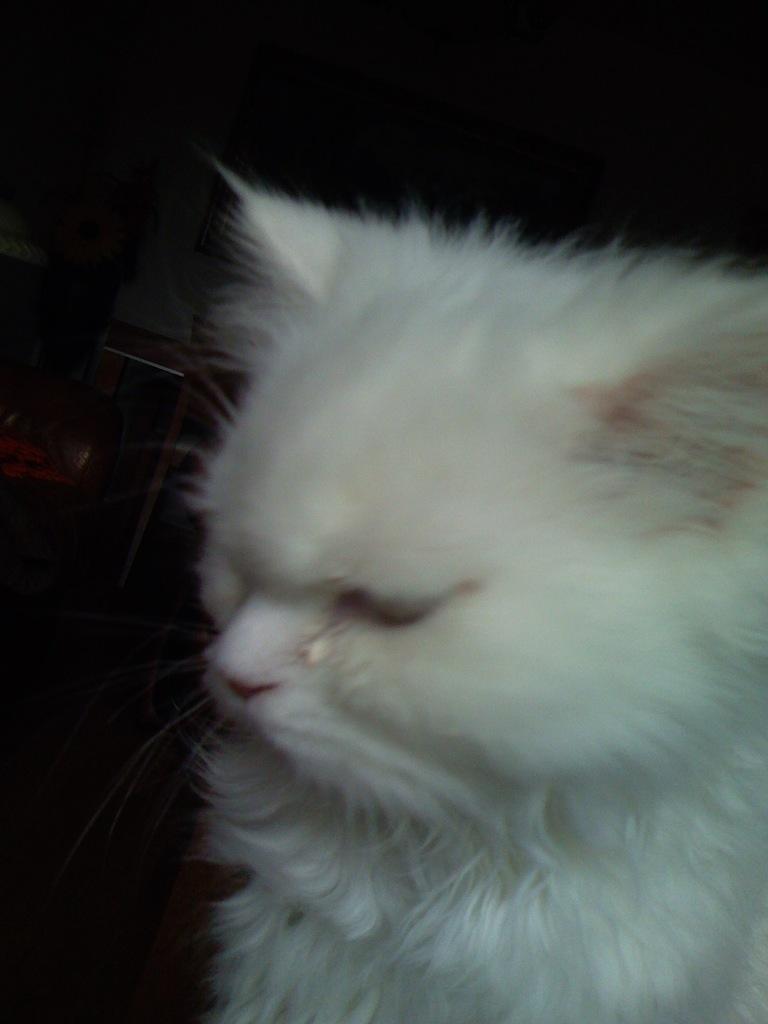Describe this image in one or two sentences. In this image there is a cat, in the background it is dark. 